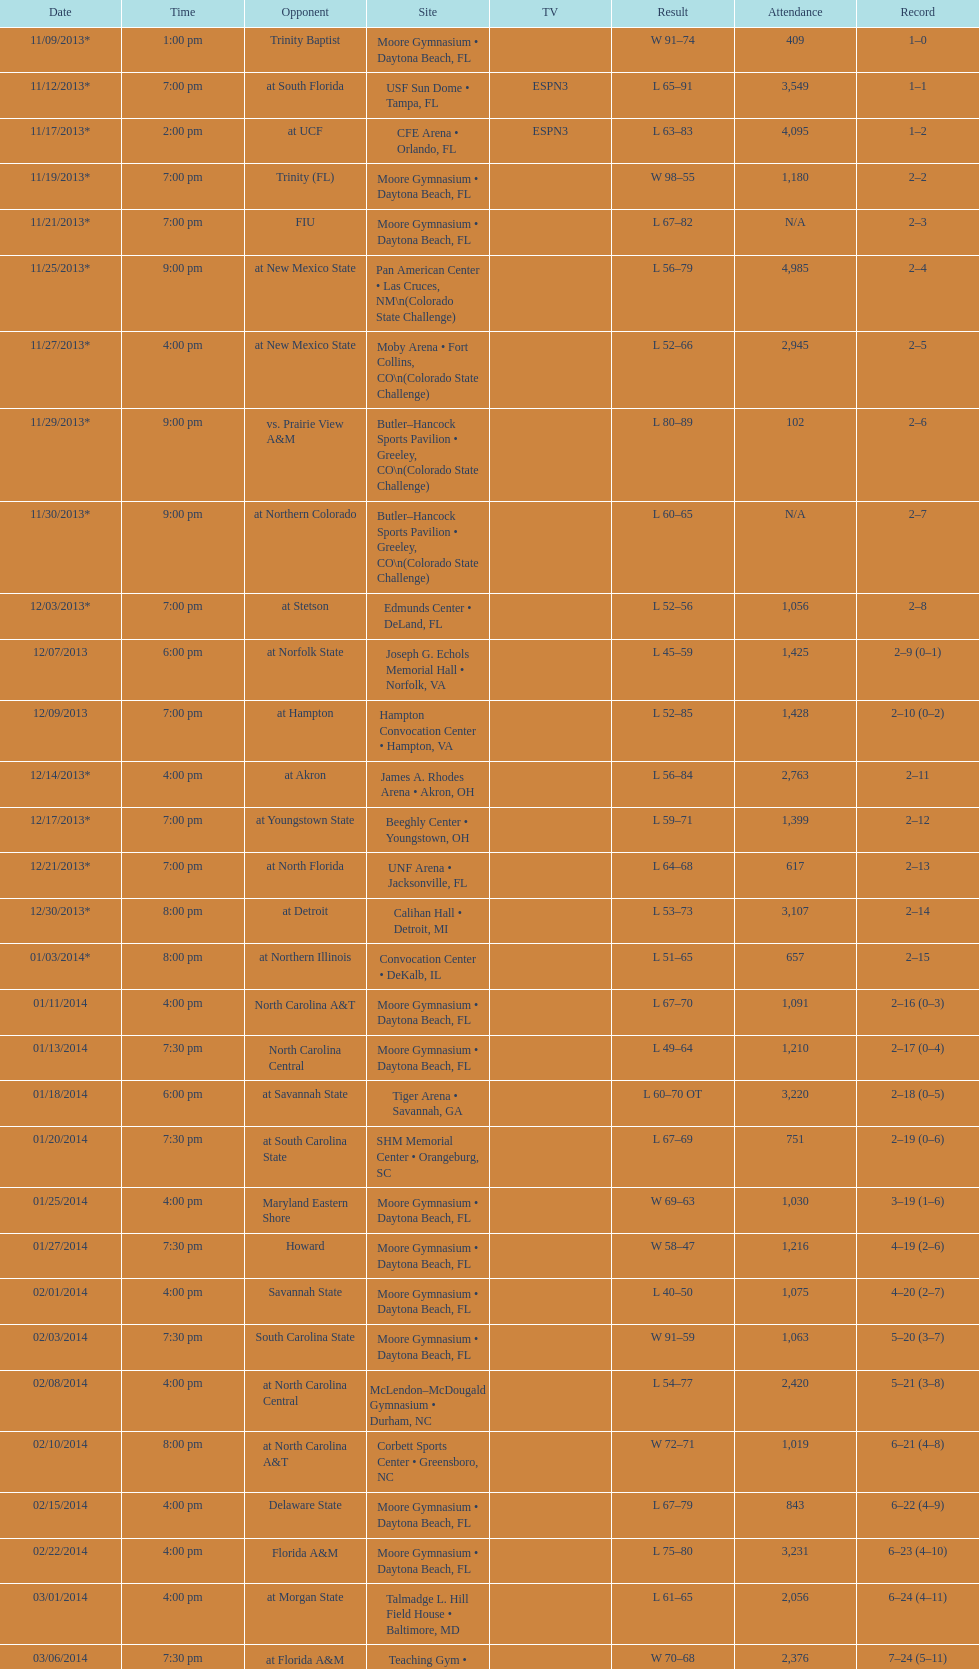In how many teams was the attendance limited to 1,000 or fewer? 6. 